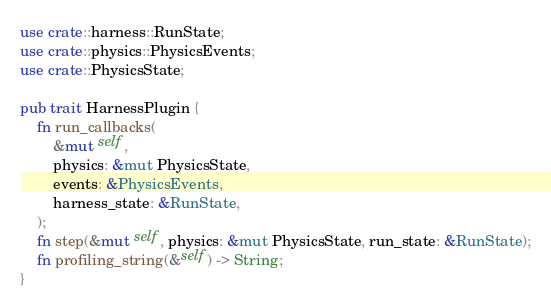Convert code to text. <code><loc_0><loc_0><loc_500><loc_500><_Rust_>use crate::harness::RunState;
use crate::physics::PhysicsEvents;
use crate::PhysicsState;

pub trait HarnessPlugin {
    fn run_callbacks(
        &mut self,
        physics: &mut PhysicsState,
        events: &PhysicsEvents,
        harness_state: &RunState,
    );
    fn step(&mut self, physics: &mut PhysicsState, run_state: &RunState);
    fn profiling_string(&self) -> String;
}
</code> 